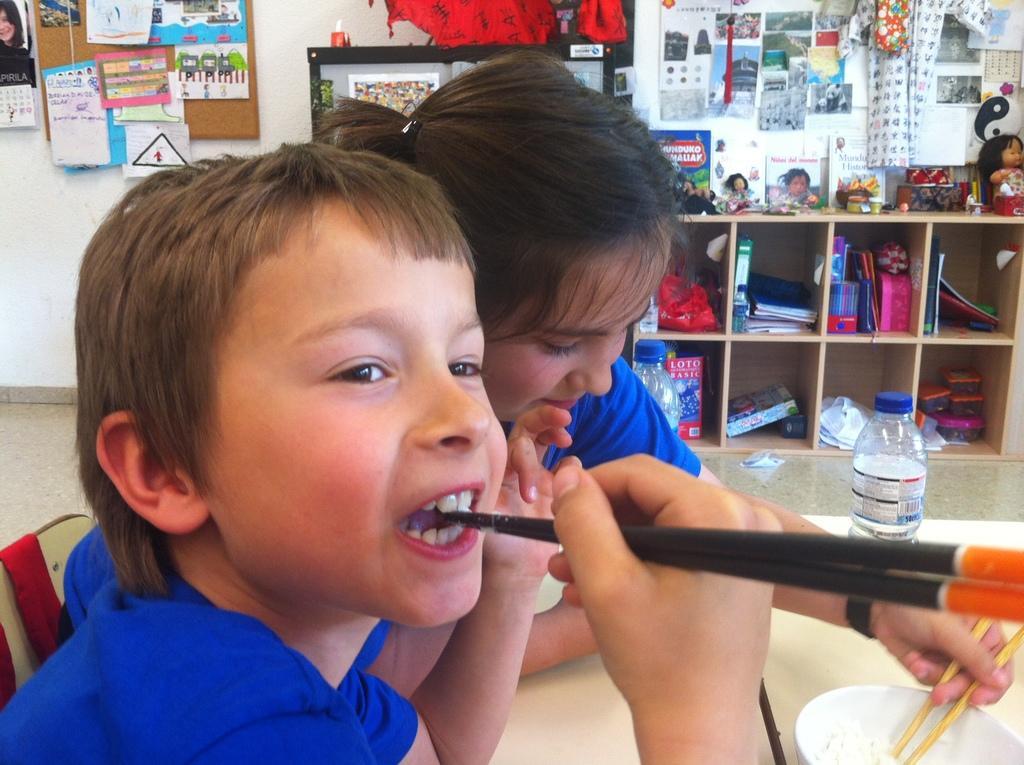Could you give a brief overview of what you see in this image? It is a room there are two kids sitting in front of the table , both of them are wearing blue shirt, first kid is is putting chopsticks into his mouth the second kid is trying to eat something using the chopsticks from a bowl,there is a bottle on the table behind these kids there are some books, toys, calendars, posters,pens, pencils etc. in the shelf ,there is also a notice board some posters are stick on it , in the background there is a white color wall. 